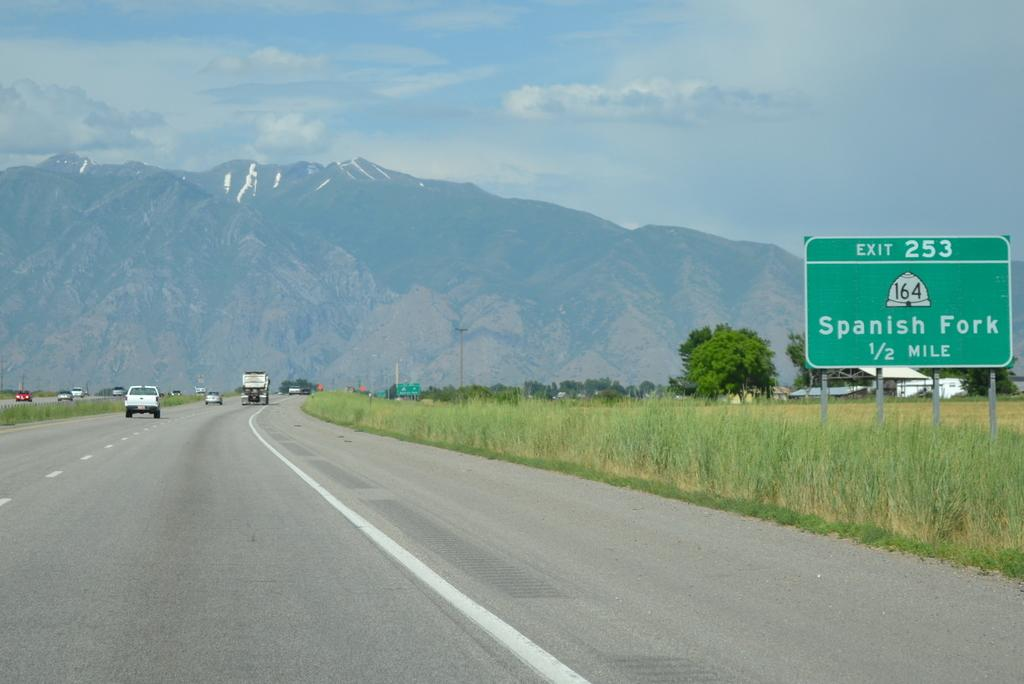<image>
Relay a brief, clear account of the picture shown. Highway sign displays distance to exit for the famous Spanish Fork 